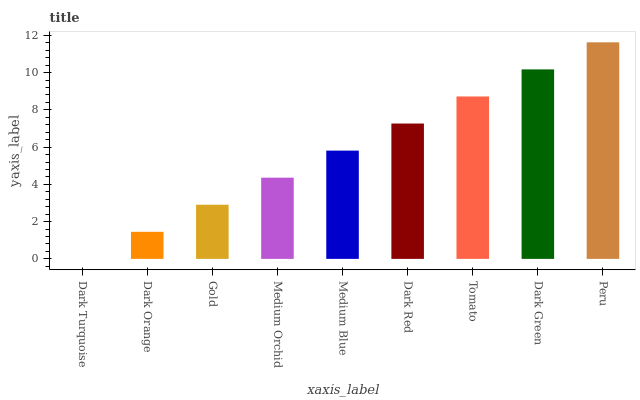Is Dark Turquoise the minimum?
Answer yes or no. Yes. Is Peru the maximum?
Answer yes or no. Yes. Is Dark Orange the minimum?
Answer yes or no. No. Is Dark Orange the maximum?
Answer yes or no. No. Is Dark Orange greater than Dark Turquoise?
Answer yes or no. Yes. Is Dark Turquoise less than Dark Orange?
Answer yes or no. Yes. Is Dark Turquoise greater than Dark Orange?
Answer yes or no. No. Is Dark Orange less than Dark Turquoise?
Answer yes or no. No. Is Medium Blue the high median?
Answer yes or no. Yes. Is Medium Blue the low median?
Answer yes or no. Yes. Is Dark Red the high median?
Answer yes or no. No. Is Dark Orange the low median?
Answer yes or no. No. 